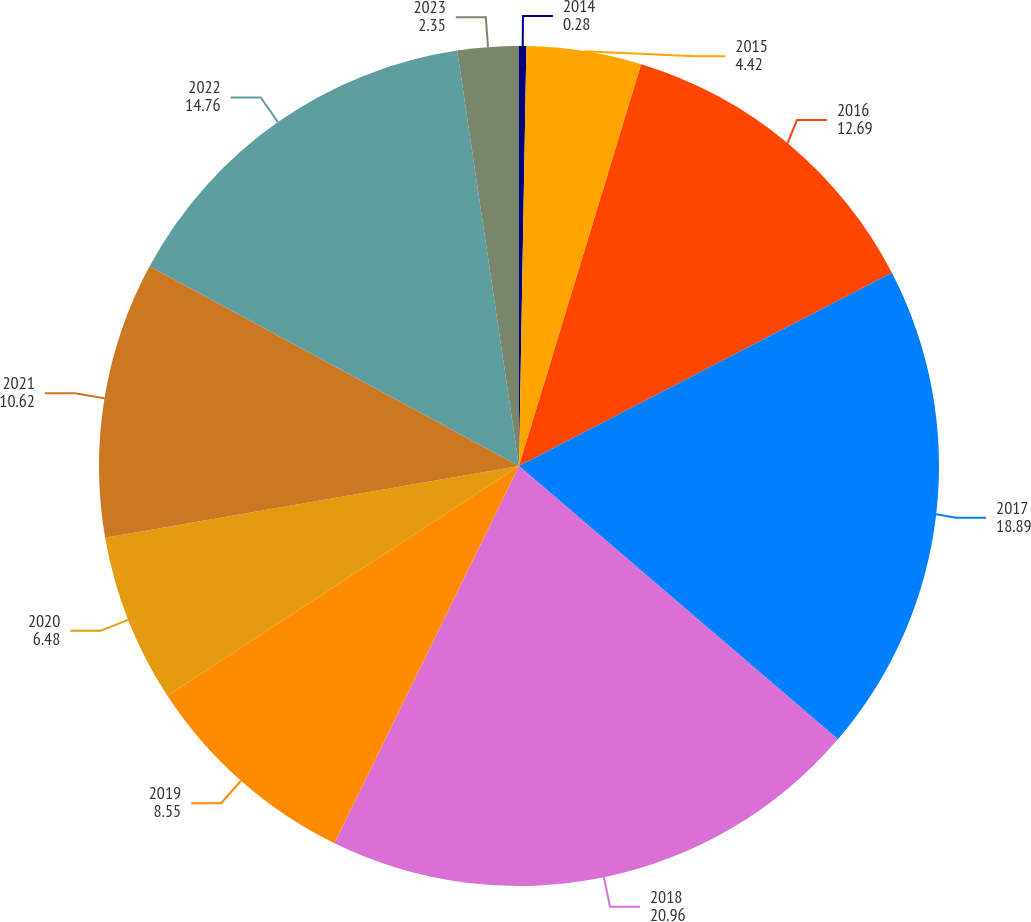Convert chart to OTSL. <chart><loc_0><loc_0><loc_500><loc_500><pie_chart><fcel>2014<fcel>2015<fcel>2016<fcel>2017<fcel>2018<fcel>2019<fcel>2020<fcel>2021<fcel>2022<fcel>2023<nl><fcel>0.28%<fcel>4.42%<fcel>12.69%<fcel>18.89%<fcel>20.96%<fcel>8.55%<fcel>6.48%<fcel>10.62%<fcel>14.76%<fcel>2.35%<nl></chart> 